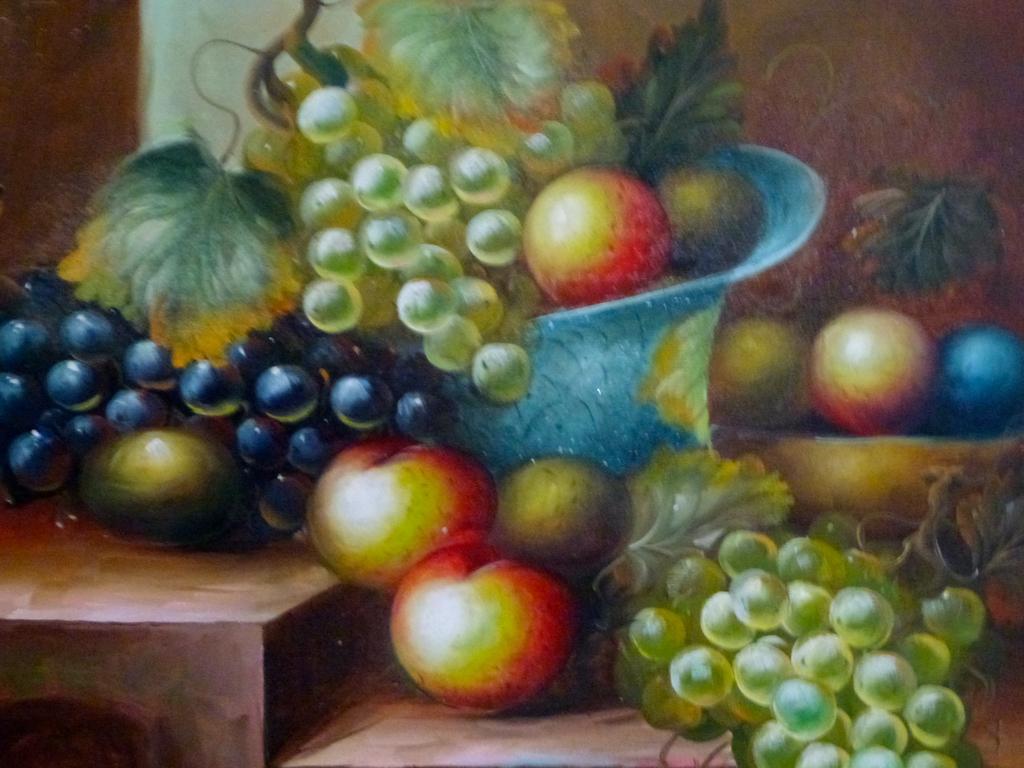In one or two sentences, can you explain what this image depicts? In this image there is an art of a few grapes and fruits. 